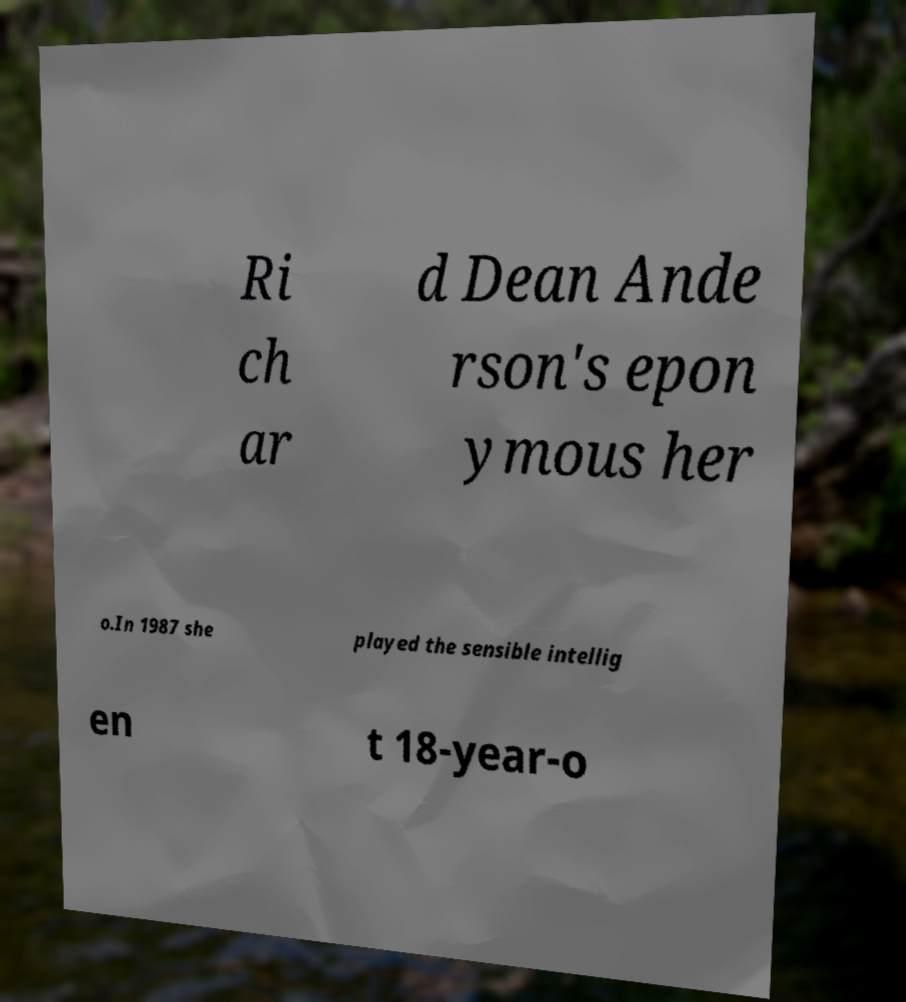Please identify and transcribe the text found in this image. Ri ch ar d Dean Ande rson's epon ymous her o.In 1987 she played the sensible intellig en t 18-year-o 